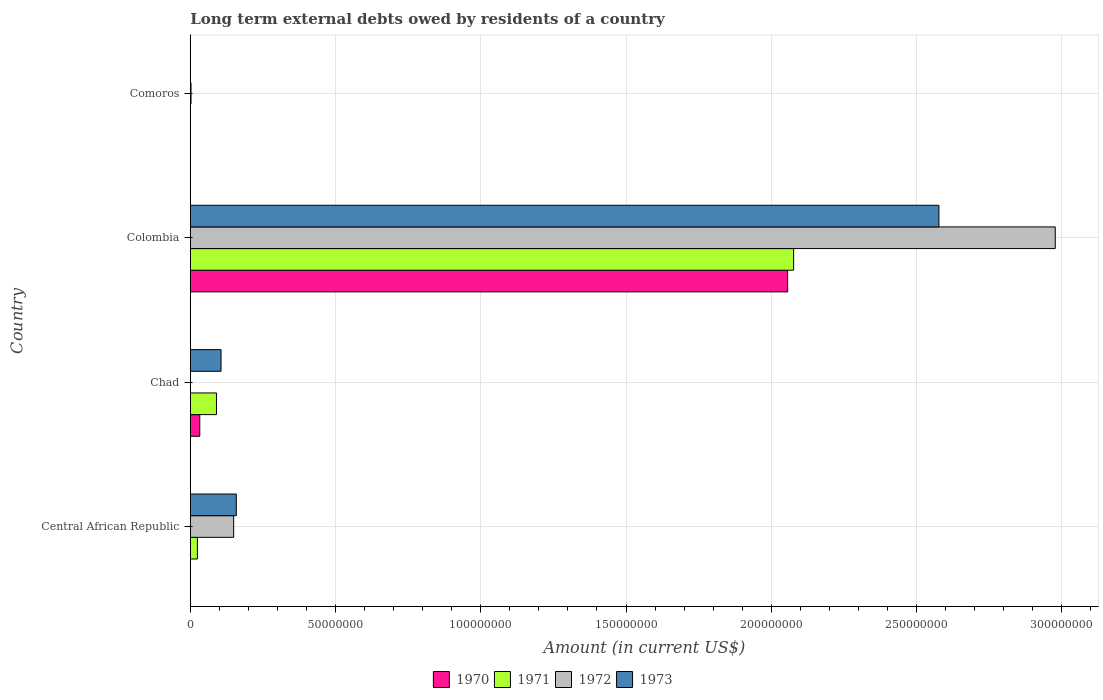How many different coloured bars are there?
Make the answer very short. 4. How many groups of bars are there?
Ensure brevity in your answer.  4. Are the number of bars per tick equal to the number of legend labels?
Your answer should be compact. No. Are the number of bars on each tick of the Y-axis equal?
Make the answer very short. No. How many bars are there on the 1st tick from the bottom?
Make the answer very short. 3. What is the label of the 4th group of bars from the top?
Provide a short and direct response. Central African Republic. What is the amount of long-term external debts owed by residents in 1971 in Chad?
Your answer should be compact. 9.01e+06. Across all countries, what is the maximum amount of long-term external debts owed by residents in 1971?
Provide a succinct answer. 2.08e+08. In which country was the amount of long-term external debts owed by residents in 1972 maximum?
Your answer should be compact. Colombia. What is the total amount of long-term external debts owed by residents in 1971 in the graph?
Your answer should be very brief. 2.19e+08. What is the difference between the amount of long-term external debts owed by residents in 1971 in Chad and that in Colombia?
Offer a terse response. -1.99e+08. What is the difference between the amount of long-term external debts owed by residents in 1971 in Colombia and the amount of long-term external debts owed by residents in 1970 in Central African Republic?
Your response must be concise. 2.08e+08. What is the average amount of long-term external debts owed by residents in 1970 per country?
Keep it short and to the point. 5.22e+07. What is the difference between the amount of long-term external debts owed by residents in 1971 and amount of long-term external debts owed by residents in 1973 in Colombia?
Provide a succinct answer. -5.00e+07. What is the ratio of the amount of long-term external debts owed by residents in 1973 in Central African Republic to that in Chad?
Your answer should be compact. 1.5. Is the amount of long-term external debts owed by residents in 1973 in Chad less than that in Colombia?
Keep it short and to the point. Yes. What is the difference between the highest and the second highest amount of long-term external debts owed by residents in 1973?
Keep it short and to the point. 2.42e+08. What is the difference between the highest and the lowest amount of long-term external debts owed by residents in 1970?
Your response must be concise. 2.06e+08. Is the sum of the amount of long-term external debts owed by residents in 1973 in Chad and Comoros greater than the maximum amount of long-term external debts owed by residents in 1972 across all countries?
Provide a succinct answer. No. Is it the case that in every country, the sum of the amount of long-term external debts owed by residents in 1972 and amount of long-term external debts owed by residents in 1971 is greater than the sum of amount of long-term external debts owed by residents in 1970 and amount of long-term external debts owed by residents in 1973?
Your response must be concise. No. Is it the case that in every country, the sum of the amount of long-term external debts owed by residents in 1973 and amount of long-term external debts owed by residents in 1972 is greater than the amount of long-term external debts owed by residents in 1970?
Provide a short and direct response. Yes. How many bars are there?
Your answer should be compact. 12. Are all the bars in the graph horizontal?
Your answer should be compact. Yes. How many countries are there in the graph?
Give a very brief answer. 4. Are the values on the major ticks of X-axis written in scientific E-notation?
Your answer should be compact. No. Where does the legend appear in the graph?
Provide a succinct answer. Bottom center. How many legend labels are there?
Give a very brief answer. 4. How are the legend labels stacked?
Keep it short and to the point. Horizontal. What is the title of the graph?
Offer a terse response. Long term external debts owed by residents of a country. What is the Amount (in current US$) of 1971 in Central African Republic?
Ensure brevity in your answer.  2.45e+06. What is the Amount (in current US$) in 1972 in Central African Republic?
Offer a very short reply. 1.49e+07. What is the Amount (in current US$) of 1973 in Central African Republic?
Provide a short and direct response. 1.58e+07. What is the Amount (in current US$) of 1970 in Chad?
Your answer should be compact. 3.26e+06. What is the Amount (in current US$) of 1971 in Chad?
Make the answer very short. 9.01e+06. What is the Amount (in current US$) in 1973 in Chad?
Offer a very short reply. 1.06e+07. What is the Amount (in current US$) of 1970 in Colombia?
Give a very brief answer. 2.06e+08. What is the Amount (in current US$) of 1971 in Colombia?
Ensure brevity in your answer.  2.08e+08. What is the Amount (in current US$) in 1972 in Colombia?
Your answer should be compact. 2.98e+08. What is the Amount (in current US$) of 1973 in Colombia?
Provide a short and direct response. 2.58e+08. What is the Amount (in current US$) in 1970 in Comoros?
Offer a very short reply. 0. What is the Amount (in current US$) of 1971 in Comoros?
Provide a short and direct response. 0. What is the Amount (in current US$) of 1972 in Comoros?
Give a very brief answer. 2.48e+05. What is the Amount (in current US$) in 1973 in Comoros?
Give a very brief answer. 5.40e+04. Across all countries, what is the maximum Amount (in current US$) of 1970?
Your response must be concise. 2.06e+08. Across all countries, what is the maximum Amount (in current US$) in 1971?
Give a very brief answer. 2.08e+08. Across all countries, what is the maximum Amount (in current US$) in 1972?
Provide a succinct answer. 2.98e+08. Across all countries, what is the maximum Amount (in current US$) in 1973?
Provide a succinct answer. 2.58e+08. Across all countries, what is the minimum Amount (in current US$) in 1970?
Give a very brief answer. 0. Across all countries, what is the minimum Amount (in current US$) of 1971?
Provide a short and direct response. 0. Across all countries, what is the minimum Amount (in current US$) in 1973?
Make the answer very short. 5.40e+04. What is the total Amount (in current US$) of 1970 in the graph?
Your response must be concise. 2.09e+08. What is the total Amount (in current US$) in 1971 in the graph?
Your response must be concise. 2.19e+08. What is the total Amount (in current US$) in 1972 in the graph?
Make the answer very short. 3.13e+08. What is the total Amount (in current US$) of 1973 in the graph?
Offer a very short reply. 2.84e+08. What is the difference between the Amount (in current US$) in 1971 in Central African Republic and that in Chad?
Give a very brief answer. -6.56e+06. What is the difference between the Amount (in current US$) in 1973 in Central African Republic and that in Chad?
Keep it short and to the point. 5.26e+06. What is the difference between the Amount (in current US$) in 1971 in Central African Republic and that in Colombia?
Give a very brief answer. -2.05e+08. What is the difference between the Amount (in current US$) of 1972 in Central African Republic and that in Colombia?
Your response must be concise. -2.83e+08. What is the difference between the Amount (in current US$) of 1973 in Central African Republic and that in Colombia?
Offer a terse response. -2.42e+08. What is the difference between the Amount (in current US$) of 1972 in Central African Republic and that in Comoros?
Your response must be concise. 1.47e+07. What is the difference between the Amount (in current US$) in 1973 in Central African Republic and that in Comoros?
Offer a very short reply. 1.58e+07. What is the difference between the Amount (in current US$) in 1970 in Chad and that in Colombia?
Offer a very short reply. -2.02e+08. What is the difference between the Amount (in current US$) of 1971 in Chad and that in Colombia?
Give a very brief answer. -1.99e+08. What is the difference between the Amount (in current US$) in 1973 in Chad and that in Colombia?
Ensure brevity in your answer.  -2.47e+08. What is the difference between the Amount (in current US$) in 1973 in Chad and that in Comoros?
Make the answer very short. 1.05e+07. What is the difference between the Amount (in current US$) of 1972 in Colombia and that in Comoros?
Provide a succinct answer. 2.98e+08. What is the difference between the Amount (in current US$) in 1973 in Colombia and that in Comoros?
Make the answer very short. 2.58e+08. What is the difference between the Amount (in current US$) in 1971 in Central African Republic and the Amount (in current US$) in 1973 in Chad?
Keep it short and to the point. -8.13e+06. What is the difference between the Amount (in current US$) in 1972 in Central African Republic and the Amount (in current US$) in 1973 in Chad?
Give a very brief answer. 4.35e+06. What is the difference between the Amount (in current US$) in 1971 in Central African Republic and the Amount (in current US$) in 1972 in Colombia?
Provide a succinct answer. -2.95e+08. What is the difference between the Amount (in current US$) of 1971 in Central African Republic and the Amount (in current US$) of 1973 in Colombia?
Offer a terse response. -2.55e+08. What is the difference between the Amount (in current US$) of 1972 in Central African Republic and the Amount (in current US$) of 1973 in Colombia?
Your answer should be very brief. -2.43e+08. What is the difference between the Amount (in current US$) in 1971 in Central African Republic and the Amount (in current US$) in 1972 in Comoros?
Your response must be concise. 2.20e+06. What is the difference between the Amount (in current US$) of 1971 in Central African Republic and the Amount (in current US$) of 1973 in Comoros?
Offer a terse response. 2.40e+06. What is the difference between the Amount (in current US$) of 1972 in Central African Republic and the Amount (in current US$) of 1973 in Comoros?
Make the answer very short. 1.49e+07. What is the difference between the Amount (in current US$) in 1970 in Chad and the Amount (in current US$) in 1971 in Colombia?
Provide a short and direct response. -2.04e+08. What is the difference between the Amount (in current US$) of 1970 in Chad and the Amount (in current US$) of 1972 in Colombia?
Give a very brief answer. -2.94e+08. What is the difference between the Amount (in current US$) in 1970 in Chad and the Amount (in current US$) in 1973 in Colombia?
Provide a succinct answer. -2.54e+08. What is the difference between the Amount (in current US$) of 1971 in Chad and the Amount (in current US$) of 1972 in Colombia?
Give a very brief answer. -2.89e+08. What is the difference between the Amount (in current US$) of 1971 in Chad and the Amount (in current US$) of 1973 in Colombia?
Provide a short and direct response. -2.49e+08. What is the difference between the Amount (in current US$) of 1970 in Chad and the Amount (in current US$) of 1972 in Comoros?
Give a very brief answer. 3.02e+06. What is the difference between the Amount (in current US$) in 1970 in Chad and the Amount (in current US$) in 1973 in Comoros?
Offer a very short reply. 3.21e+06. What is the difference between the Amount (in current US$) of 1971 in Chad and the Amount (in current US$) of 1972 in Comoros?
Ensure brevity in your answer.  8.76e+06. What is the difference between the Amount (in current US$) in 1971 in Chad and the Amount (in current US$) in 1973 in Comoros?
Offer a very short reply. 8.95e+06. What is the difference between the Amount (in current US$) in 1970 in Colombia and the Amount (in current US$) in 1972 in Comoros?
Offer a terse response. 2.05e+08. What is the difference between the Amount (in current US$) in 1970 in Colombia and the Amount (in current US$) in 1973 in Comoros?
Keep it short and to the point. 2.06e+08. What is the difference between the Amount (in current US$) in 1971 in Colombia and the Amount (in current US$) in 1972 in Comoros?
Your answer should be compact. 2.07e+08. What is the difference between the Amount (in current US$) of 1971 in Colombia and the Amount (in current US$) of 1973 in Comoros?
Make the answer very short. 2.08e+08. What is the difference between the Amount (in current US$) in 1972 in Colombia and the Amount (in current US$) in 1973 in Comoros?
Make the answer very short. 2.98e+08. What is the average Amount (in current US$) of 1970 per country?
Give a very brief answer. 5.22e+07. What is the average Amount (in current US$) in 1971 per country?
Provide a short and direct response. 5.48e+07. What is the average Amount (in current US$) of 1972 per country?
Make the answer very short. 7.82e+07. What is the average Amount (in current US$) of 1973 per country?
Ensure brevity in your answer.  7.10e+07. What is the difference between the Amount (in current US$) in 1971 and Amount (in current US$) in 1972 in Central African Republic?
Your answer should be compact. -1.25e+07. What is the difference between the Amount (in current US$) in 1971 and Amount (in current US$) in 1973 in Central African Republic?
Provide a succinct answer. -1.34e+07. What is the difference between the Amount (in current US$) of 1972 and Amount (in current US$) of 1973 in Central African Republic?
Your response must be concise. -9.04e+05. What is the difference between the Amount (in current US$) of 1970 and Amount (in current US$) of 1971 in Chad?
Make the answer very short. -5.74e+06. What is the difference between the Amount (in current US$) in 1970 and Amount (in current US$) in 1973 in Chad?
Offer a terse response. -7.32e+06. What is the difference between the Amount (in current US$) of 1971 and Amount (in current US$) of 1973 in Chad?
Ensure brevity in your answer.  -1.57e+06. What is the difference between the Amount (in current US$) in 1970 and Amount (in current US$) in 1971 in Colombia?
Your answer should be compact. -2.06e+06. What is the difference between the Amount (in current US$) in 1970 and Amount (in current US$) in 1972 in Colombia?
Your answer should be very brief. -9.21e+07. What is the difference between the Amount (in current US$) of 1970 and Amount (in current US$) of 1973 in Colombia?
Your answer should be very brief. -5.21e+07. What is the difference between the Amount (in current US$) in 1971 and Amount (in current US$) in 1972 in Colombia?
Ensure brevity in your answer.  -9.01e+07. What is the difference between the Amount (in current US$) of 1971 and Amount (in current US$) of 1973 in Colombia?
Ensure brevity in your answer.  -5.00e+07. What is the difference between the Amount (in current US$) of 1972 and Amount (in current US$) of 1973 in Colombia?
Your answer should be very brief. 4.00e+07. What is the difference between the Amount (in current US$) in 1972 and Amount (in current US$) in 1973 in Comoros?
Offer a very short reply. 1.94e+05. What is the ratio of the Amount (in current US$) in 1971 in Central African Republic to that in Chad?
Ensure brevity in your answer.  0.27. What is the ratio of the Amount (in current US$) of 1973 in Central African Republic to that in Chad?
Provide a succinct answer. 1.5. What is the ratio of the Amount (in current US$) of 1971 in Central African Republic to that in Colombia?
Give a very brief answer. 0.01. What is the ratio of the Amount (in current US$) of 1972 in Central African Republic to that in Colombia?
Your answer should be compact. 0.05. What is the ratio of the Amount (in current US$) of 1973 in Central African Republic to that in Colombia?
Keep it short and to the point. 0.06. What is the ratio of the Amount (in current US$) of 1972 in Central African Republic to that in Comoros?
Offer a terse response. 60.21. What is the ratio of the Amount (in current US$) of 1973 in Central African Republic to that in Comoros?
Your response must be concise. 293.26. What is the ratio of the Amount (in current US$) in 1970 in Chad to that in Colombia?
Give a very brief answer. 0.02. What is the ratio of the Amount (in current US$) of 1971 in Chad to that in Colombia?
Your answer should be compact. 0.04. What is the ratio of the Amount (in current US$) in 1973 in Chad to that in Colombia?
Provide a short and direct response. 0.04. What is the ratio of the Amount (in current US$) in 1973 in Chad to that in Comoros?
Your answer should be compact. 195.94. What is the ratio of the Amount (in current US$) of 1972 in Colombia to that in Comoros?
Offer a terse response. 1200.66. What is the ratio of the Amount (in current US$) of 1973 in Colombia to that in Comoros?
Your answer should be compact. 4772.54. What is the difference between the highest and the second highest Amount (in current US$) of 1971?
Provide a succinct answer. 1.99e+08. What is the difference between the highest and the second highest Amount (in current US$) of 1972?
Provide a short and direct response. 2.83e+08. What is the difference between the highest and the second highest Amount (in current US$) of 1973?
Your answer should be compact. 2.42e+08. What is the difference between the highest and the lowest Amount (in current US$) in 1970?
Provide a short and direct response. 2.06e+08. What is the difference between the highest and the lowest Amount (in current US$) of 1971?
Ensure brevity in your answer.  2.08e+08. What is the difference between the highest and the lowest Amount (in current US$) in 1972?
Your answer should be compact. 2.98e+08. What is the difference between the highest and the lowest Amount (in current US$) of 1973?
Provide a short and direct response. 2.58e+08. 